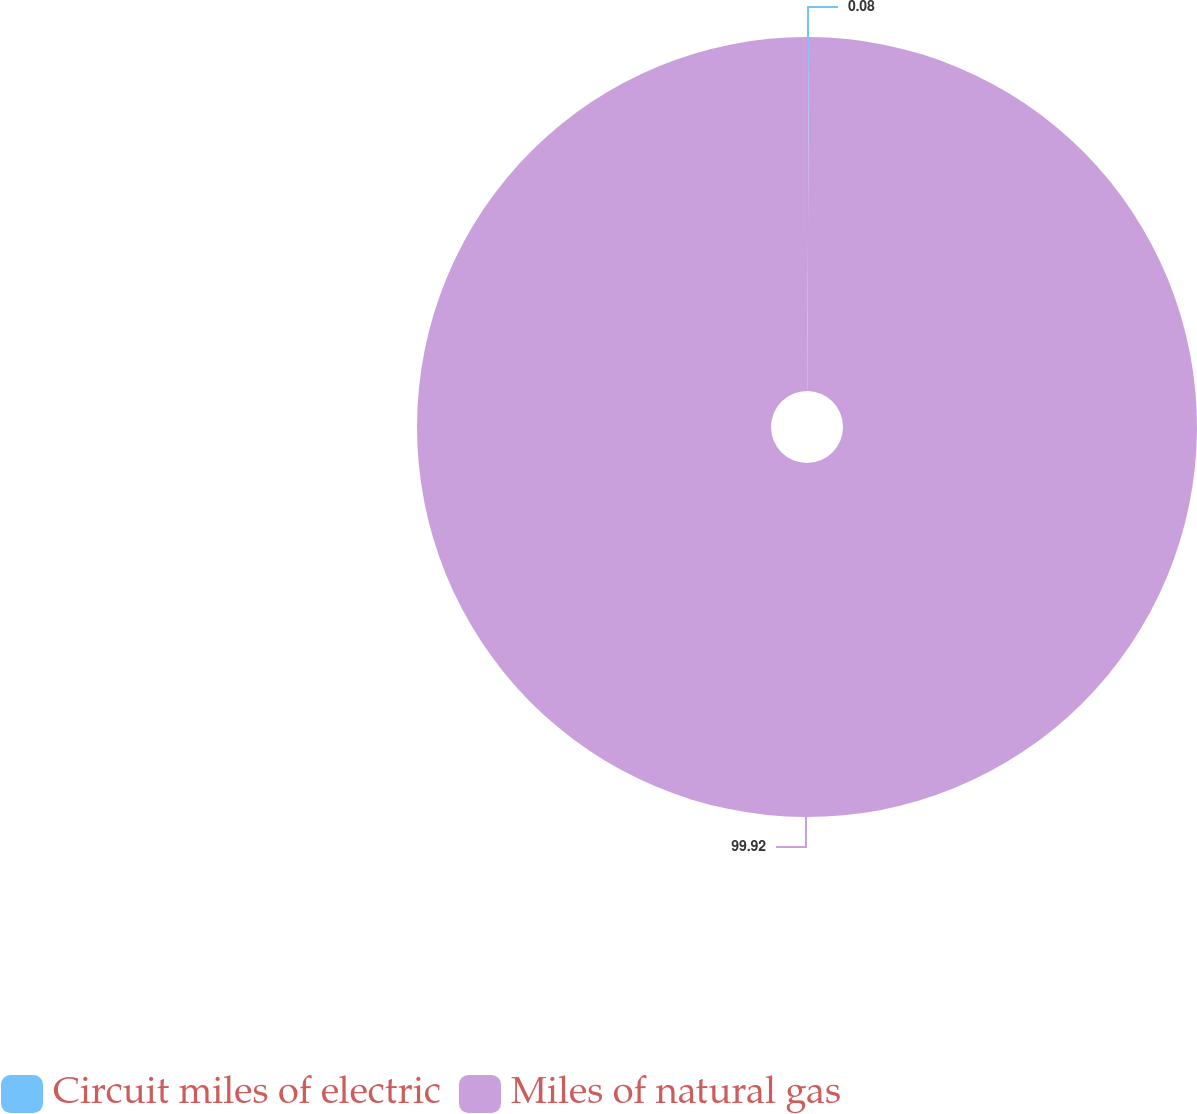Convert chart to OTSL. <chart><loc_0><loc_0><loc_500><loc_500><pie_chart><fcel>Circuit miles of electric<fcel>Miles of natural gas<nl><fcel>0.08%<fcel>99.92%<nl></chart> 